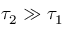<formula> <loc_0><loc_0><loc_500><loc_500>{ \tau } _ { 2 } \gg { \tau } _ { 1 }</formula> 